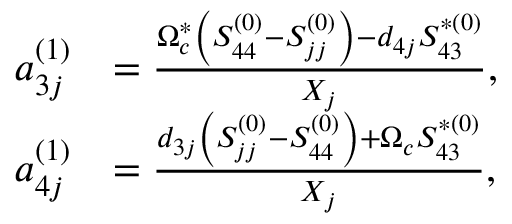Convert formula to latex. <formula><loc_0><loc_0><loc_500><loc_500>\begin{array} { r l } { a _ { 3 j } ^ { ( 1 ) } } & { = \frac { \Omega _ { c } ^ { \ast } \left ( S _ { 4 4 } ^ { ( 0 ) } - S _ { j j } ^ { ( 0 ) } \right ) - d _ { 4 j } S _ { 4 3 } ^ { \ast ( 0 ) } } { X _ { j } } , } \\ { a _ { 4 j } ^ { ( 1 ) } } & { = \frac { d _ { 3 j } \left ( S _ { j j } ^ { ( 0 ) } - S _ { 4 4 } ^ { ( 0 ) } \right ) + \Omega _ { c } S _ { 4 3 } ^ { \ast ( 0 ) } } { X _ { j } } , } \end{array}</formula> 